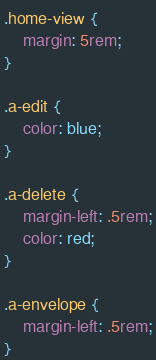<code> <loc_0><loc_0><loc_500><loc_500><_CSS_>.home-view {
    margin: 5rem;
}

.a-edit {
    color: blue;
}

.a-delete {
    margin-left: .5rem;
    color: red;
}

.a-envelope {
    margin-left: .5rem;
}</code> 